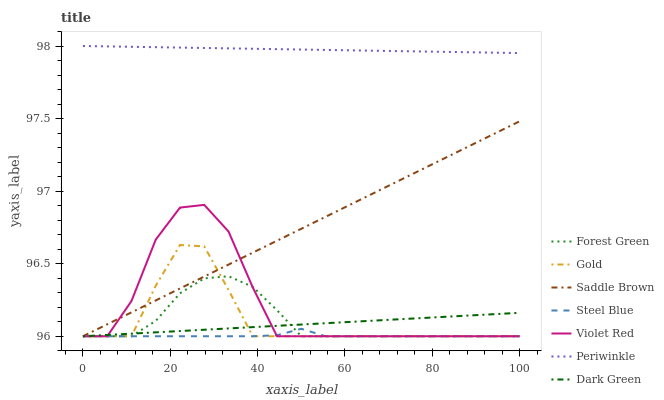Does Steel Blue have the minimum area under the curve?
Answer yes or no. Yes. Does Periwinkle have the maximum area under the curve?
Answer yes or no. Yes. Does Gold have the minimum area under the curve?
Answer yes or no. No. Does Gold have the maximum area under the curve?
Answer yes or no. No. Is Saddle Brown the smoothest?
Answer yes or no. Yes. Is Violet Red the roughest?
Answer yes or no. Yes. Is Gold the smoothest?
Answer yes or no. No. Is Gold the roughest?
Answer yes or no. No. Does Violet Red have the lowest value?
Answer yes or no. Yes. Does Periwinkle have the lowest value?
Answer yes or no. No. Does Periwinkle have the highest value?
Answer yes or no. Yes. Does Gold have the highest value?
Answer yes or no. No. Is Saddle Brown less than Periwinkle?
Answer yes or no. Yes. Is Periwinkle greater than Gold?
Answer yes or no. Yes. Does Saddle Brown intersect Forest Green?
Answer yes or no. Yes. Is Saddle Brown less than Forest Green?
Answer yes or no. No. Is Saddle Brown greater than Forest Green?
Answer yes or no. No. Does Saddle Brown intersect Periwinkle?
Answer yes or no. No. 